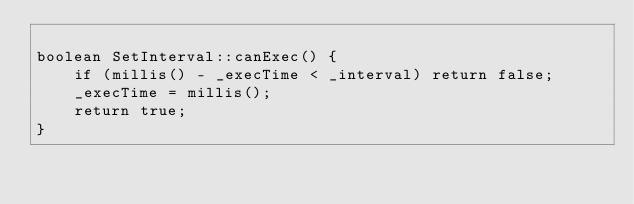<code> <loc_0><loc_0><loc_500><loc_500><_C++_>
boolean SetInterval::canExec() {
    if (millis() - _execTime < _interval) return false;
    _execTime = millis();
    return true;
}
</code> 